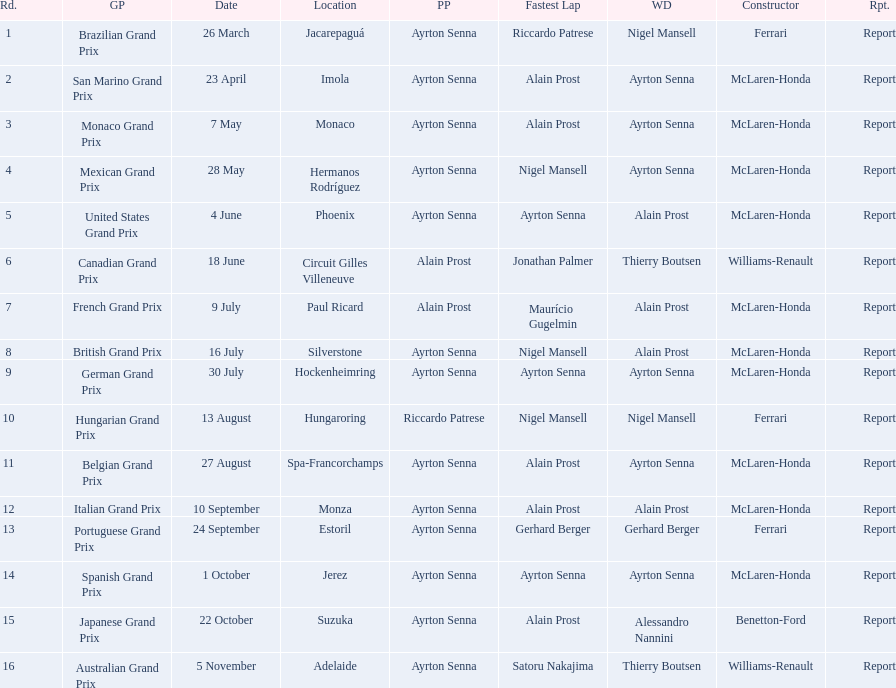Who won the spanish grand prix? McLaren-Honda. Who won the italian grand prix? McLaren-Honda. What grand prix did benneton-ford win? Japanese Grand Prix. 